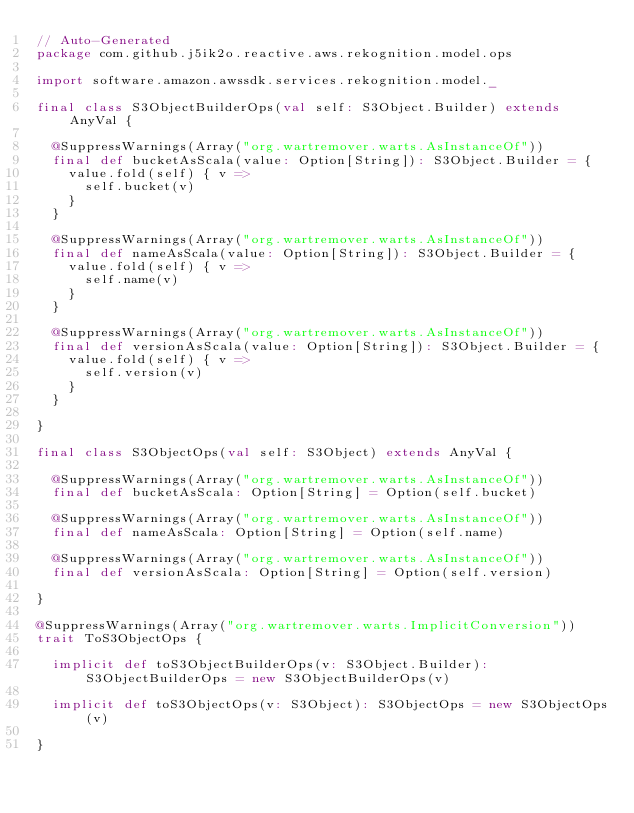<code> <loc_0><loc_0><loc_500><loc_500><_Scala_>// Auto-Generated
package com.github.j5ik2o.reactive.aws.rekognition.model.ops

import software.amazon.awssdk.services.rekognition.model._

final class S3ObjectBuilderOps(val self: S3Object.Builder) extends AnyVal {

  @SuppressWarnings(Array("org.wartremover.warts.AsInstanceOf"))
  final def bucketAsScala(value: Option[String]): S3Object.Builder = {
    value.fold(self) { v =>
      self.bucket(v)
    }
  }

  @SuppressWarnings(Array("org.wartremover.warts.AsInstanceOf"))
  final def nameAsScala(value: Option[String]): S3Object.Builder = {
    value.fold(self) { v =>
      self.name(v)
    }
  }

  @SuppressWarnings(Array("org.wartremover.warts.AsInstanceOf"))
  final def versionAsScala(value: Option[String]): S3Object.Builder = {
    value.fold(self) { v =>
      self.version(v)
    }
  }

}

final class S3ObjectOps(val self: S3Object) extends AnyVal {

  @SuppressWarnings(Array("org.wartremover.warts.AsInstanceOf"))
  final def bucketAsScala: Option[String] = Option(self.bucket)

  @SuppressWarnings(Array("org.wartremover.warts.AsInstanceOf"))
  final def nameAsScala: Option[String] = Option(self.name)

  @SuppressWarnings(Array("org.wartremover.warts.AsInstanceOf"))
  final def versionAsScala: Option[String] = Option(self.version)

}

@SuppressWarnings(Array("org.wartremover.warts.ImplicitConversion"))
trait ToS3ObjectOps {

  implicit def toS3ObjectBuilderOps(v: S3Object.Builder): S3ObjectBuilderOps = new S3ObjectBuilderOps(v)

  implicit def toS3ObjectOps(v: S3Object): S3ObjectOps = new S3ObjectOps(v)

}
</code> 